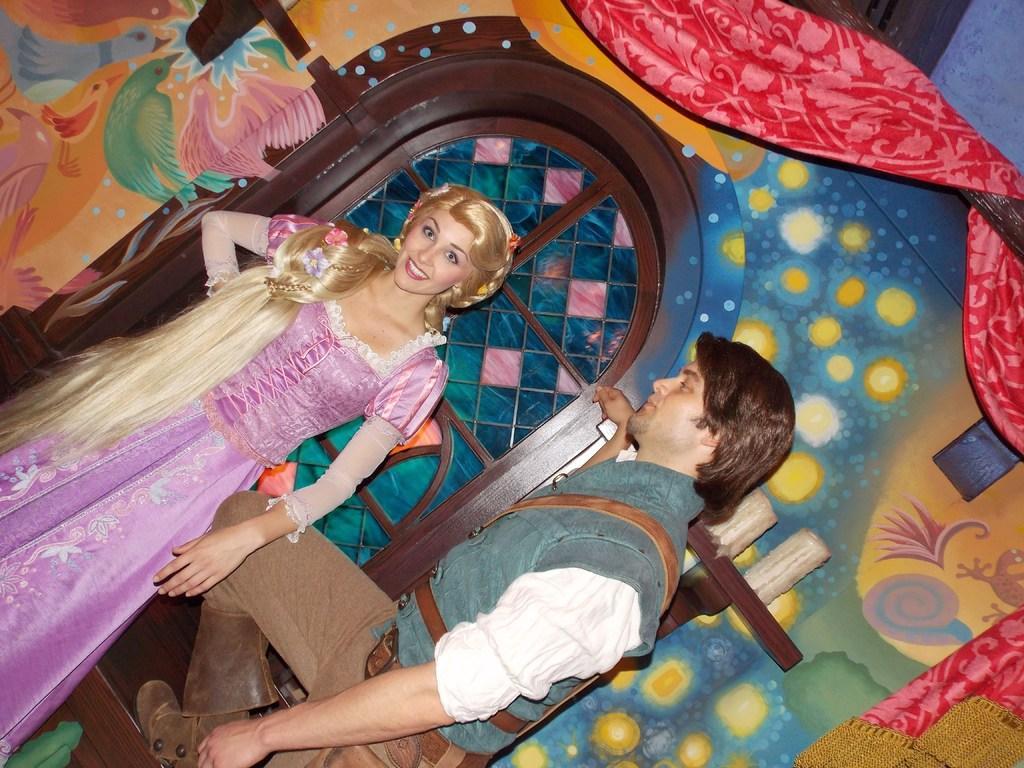Could you give a brief overview of what you see in this image? In this image there is a man and a woman, behind them there are candles on a wooden stand and there is a glass window, besides the glass window there are paintings on the wall and there is a curtain on the wooden rod. 